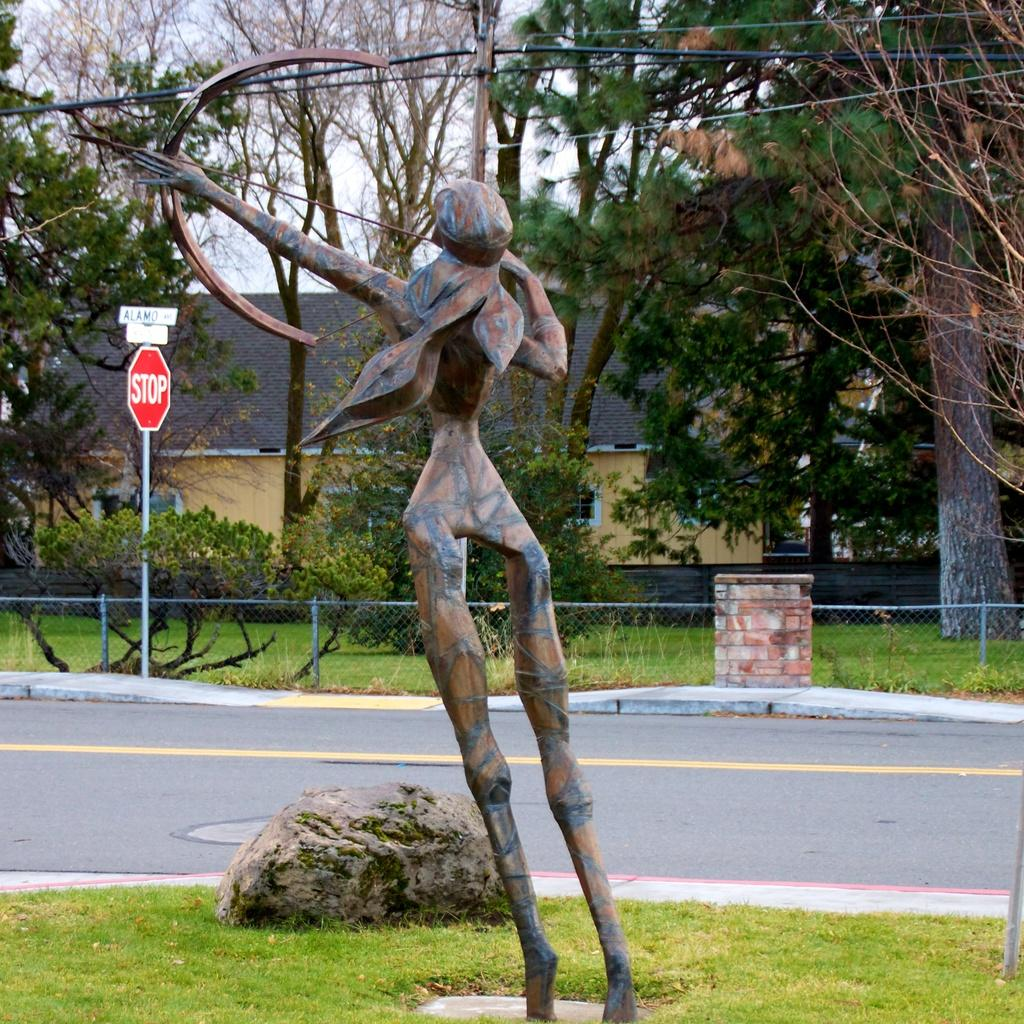What is the main subject in the image? There is a statue in the image. What can be seen in the background of the image? There are trees, sign boards, a fence, grass, and houses in the background of the image. What type of apparel is the kettle wearing in the image? There is no kettle present in the image, and therefore no apparel can be associated with it. 